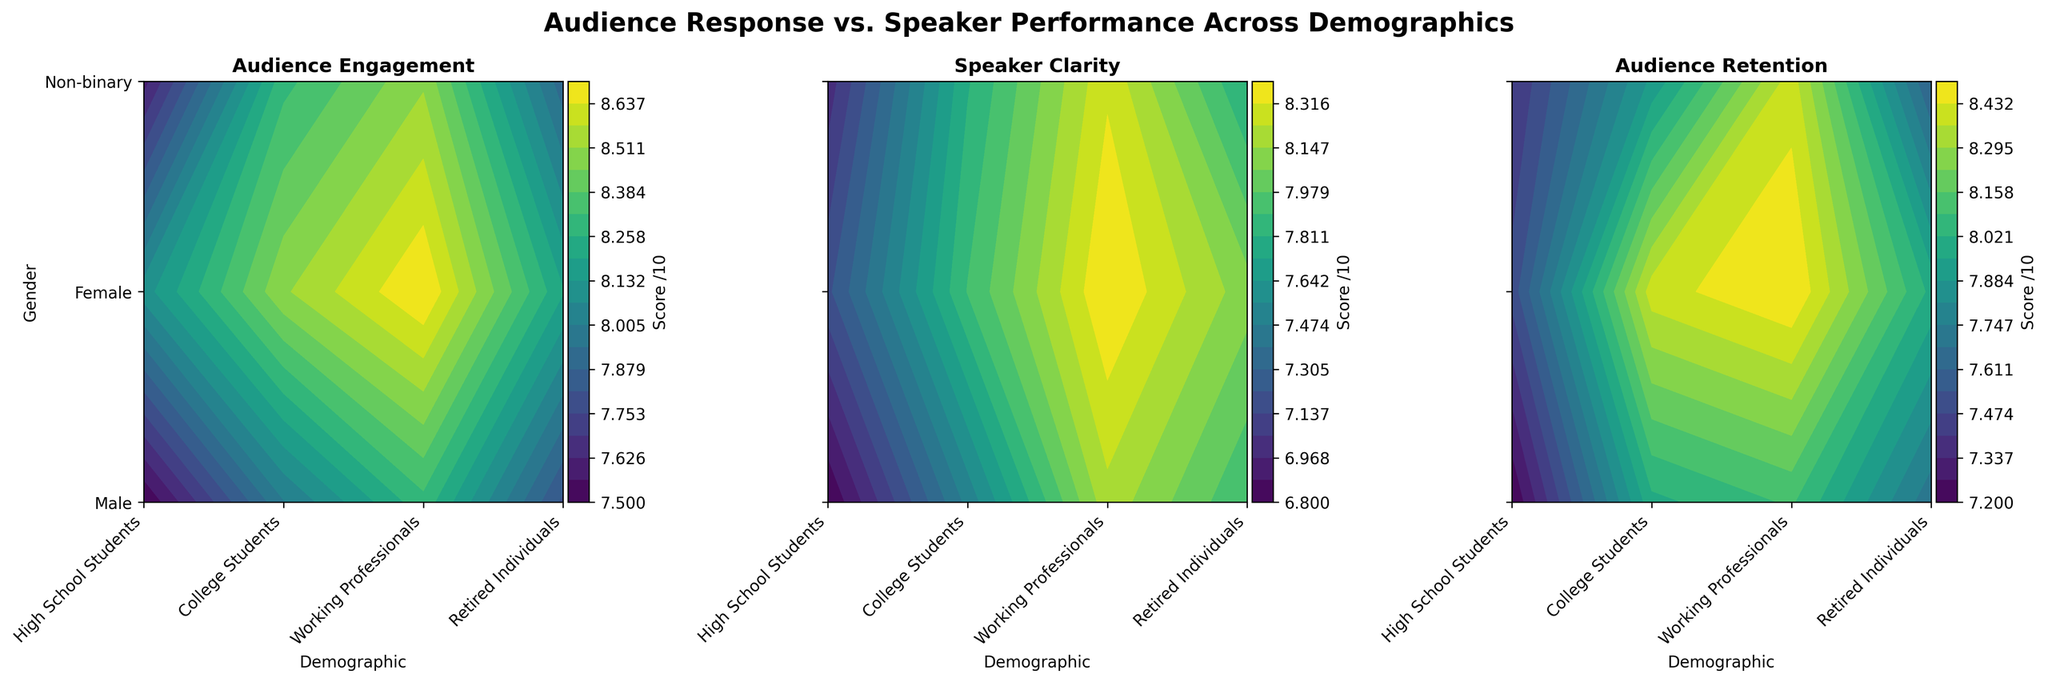What is the highest audience engagement score among working professionals? To find the highest score, we need to look at the section of the contour plot for working professionals and identify the highest engagement score. For both male, female, and non-binary, we see scores such as 8.3, 8.7, and 8.5, among which 8.7 is the highest.
Answer: 8.7 What demographic group has the lowest audience retention score? To determine the lowest audience retention score, we look across all demographic groups on the retention contour plot. High school students (male) have the lowest score, which is 7.2.
Answer: High School Students (Male) Which gender has the highest speaker clarity score? By examining the section of the contour plot related to speaker clarity, we find that working professionals (female) have the highest clarity score, which is 8.5.
Answer: Female Comparing College Students and Retired Individuals, which group has better audience engagement? We compare the audience engagement scores for college students and retired individuals. College students (female) have scores up to 8.5 and non-binary students have 8.3, which are higher compared to 8.2 (female) and 7.9 (non-binary) scores for retired individuals.
Answer: College Students What is the difference in audience retention scores between high school students (female) and working professionals (male) in the 23-35 age range? The retention score for high school students (female) is 7.5, while it is 8.1 for working professionals (male) in the 23-35 age range. The difference is 8.1 - 7.5 = 0.6.
Answer: 0.6 Which demographic group shows the highest variation in speaker clarity scores? To identify the biggest variation, we need to look for the demographic group with the largest range in clarity scores across different genders. Working professionals (23-35) have scores such as 8.2 (male), 8.4 (female), and 8.3 (non-binary), showing a minimal variation. In contrast, high school students have a bigger range with scores like 6.8 (male) and 7.2 (female), indicating the highest variation.
Answer: High School Students Which gender among college students has the best audience retention? Examining the contour plot for audience retention among college students, female students score up to 8.4, whereas males and non-binary students score 8.0 and 7.9 respectively.
Answer: Female What's the average speaker clarity score across all demographics for non-binary gender? To determine this, we sum the speaker clarity scores for non-binary gender across all demographics and divide by the total number of scores: (7.0 + 7.8 + 8.3 + 8.2 + 7.8)/5 = 7.82.
Answer: 7.82 How does audience engagement vary between males and females in the 23-35 age range? By looking at the contours for males and females in the 23-35 age range, males have a score of 8.3 while females have a slightly higher score of 8.7.
Answer: Females have higher engagement 